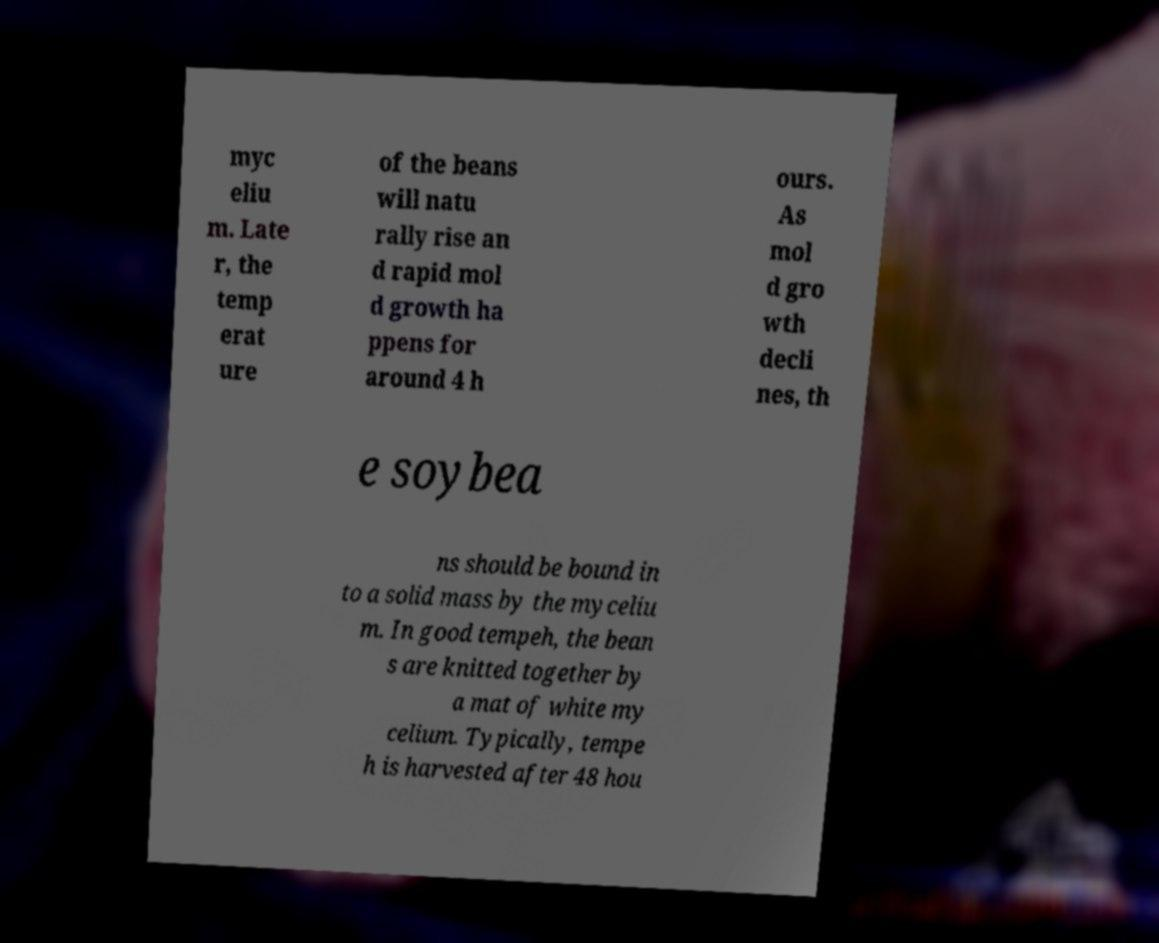Please read and relay the text visible in this image. What does it say? myc eliu m. Late r, the temp erat ure of the beans will natu rally rise an d rapid mol d growth ha ppens for around 4 h ours. As mol d gro wth decli nes, th e soybea ns should be bound in to a solid mass by the myceliu m. In good tempeh, the bean s are knitted together by a mat of white my celium. Typically, tempe h is harvested after 48 hou 